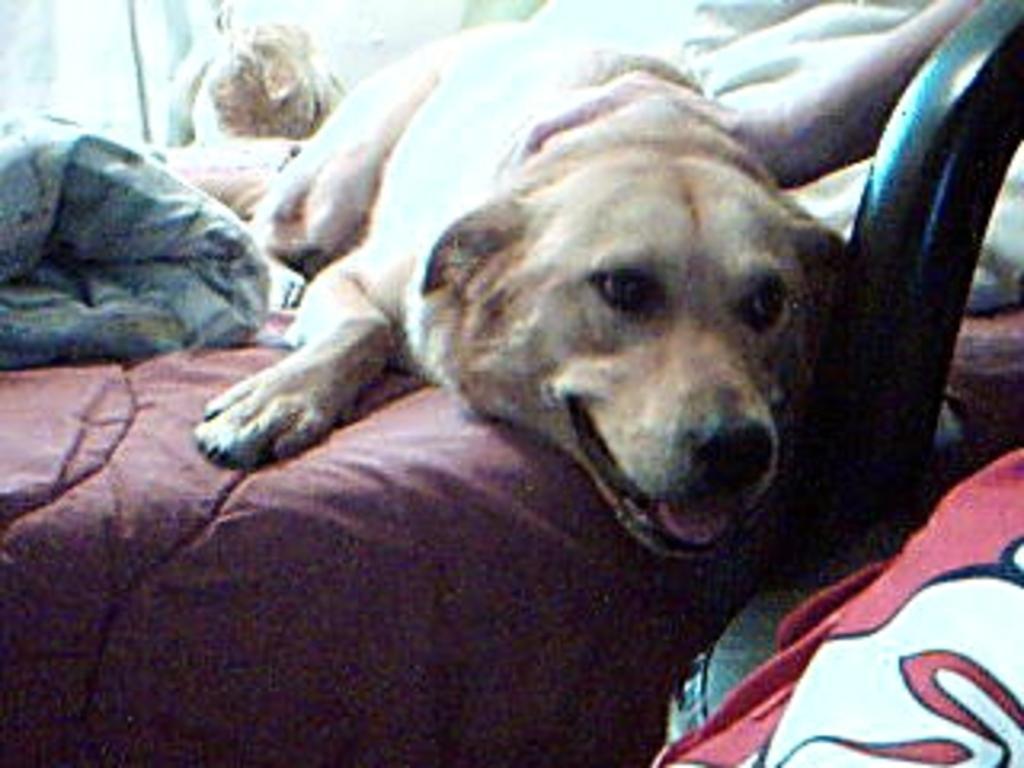Please provide a concise description of this image. In this picture we can observe a dog laying on the bed. The dog is in cream color. We can observe blanket on the bed. On the right side there is a chair. 